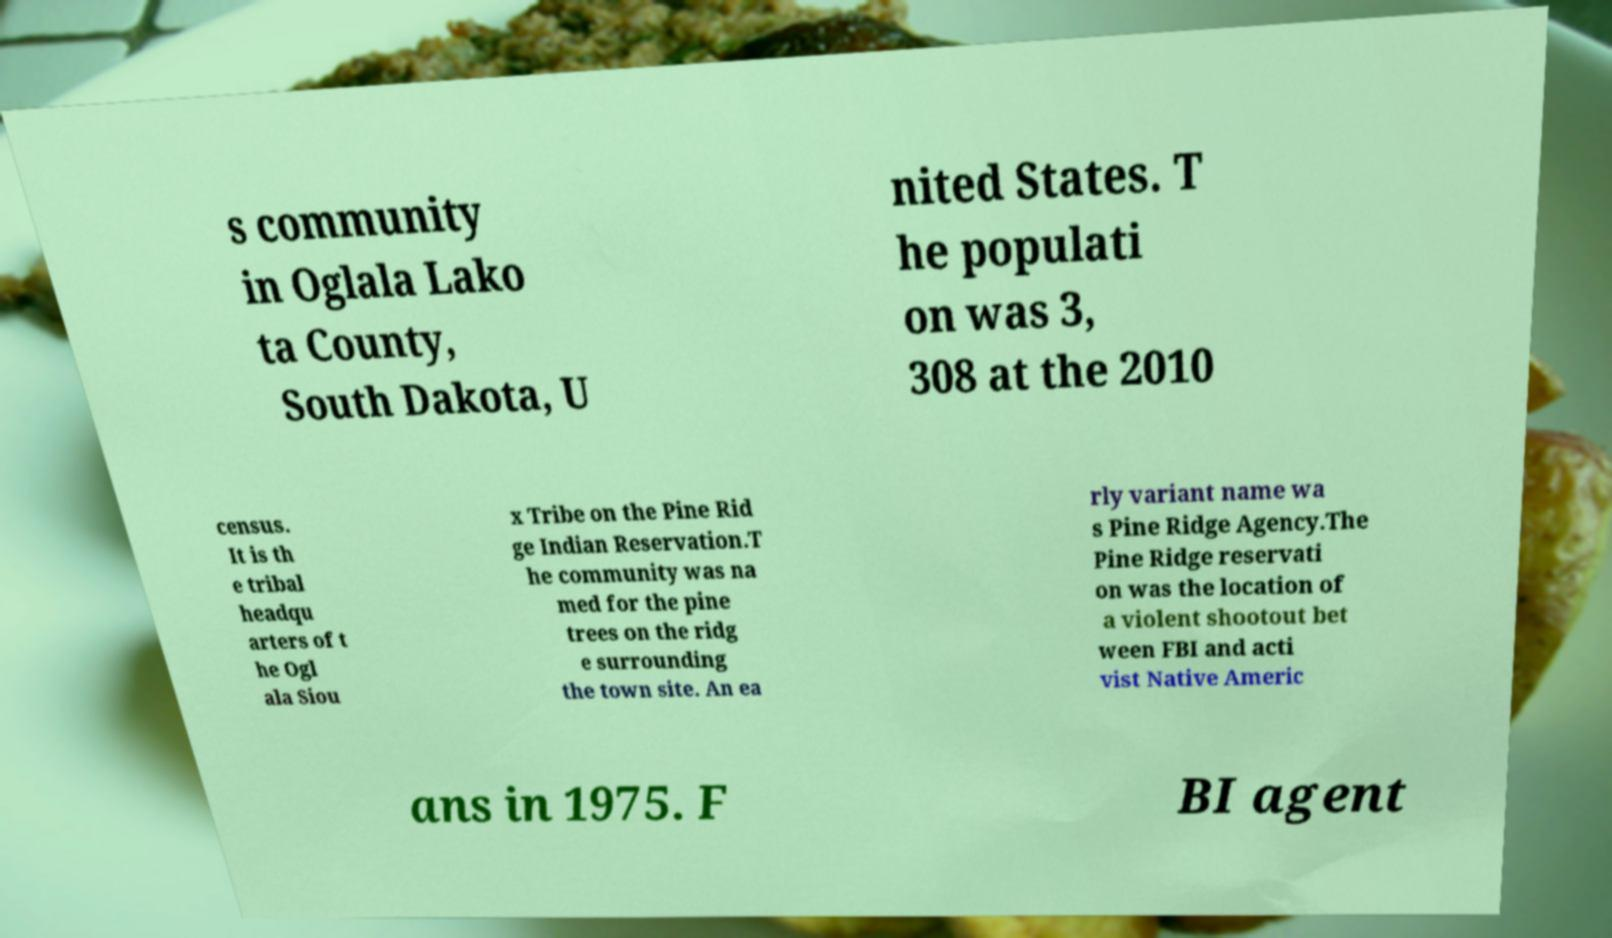Could you assist in decoding the text presented in this image and type it out clearly? s community in Oglala Lako ta County, South Dakota, U nited States. T he populati on was 3, 308 at the 2010 census. It is th e tribal headqu arters of t he Ogl ala Siou x Tribe on the Pine Rid ge Indian Reservation.T he community was na med for the pine trees on the ridg e surrounding the town site. An ea rly variant name wa s Pine Ridge Agency.The Pine Ridge reservati on was the location of a violent shootout bet ween FBI and acti vist Native Americ ans in 1975. F BI agent 